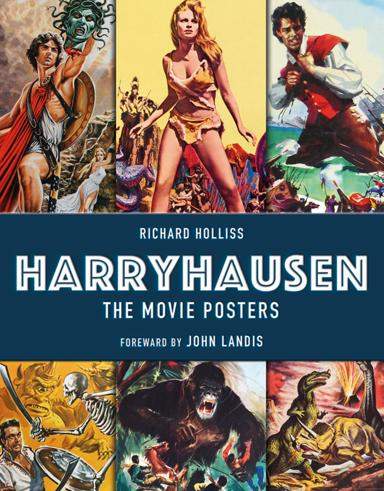Can you explain what influence Ray Harryhausen had on special effects in movies? Ray Harryhausen is renowned for revolutionizing visual effects in filmmaking during the mid-20th century, particularly through his pioneering work in stop-motion model animation. His techniques brought fantastical creatures to life and inspired generations of filmmakers and animators. 